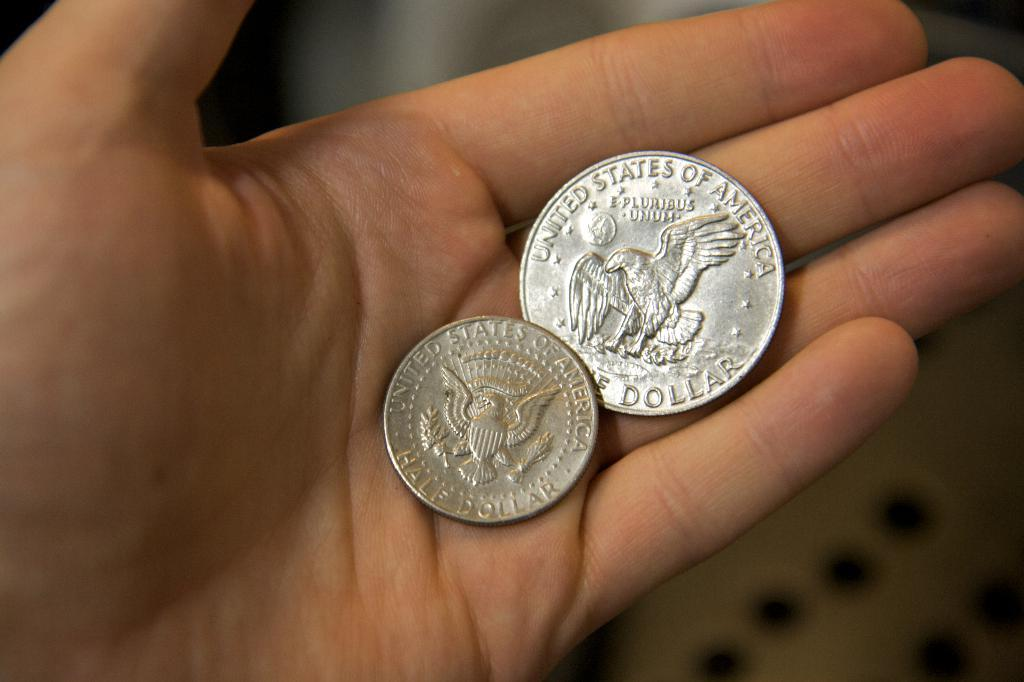Provide a one-sentence caption for the provided image. A hand is holding two different sized United States of America half dollars. 